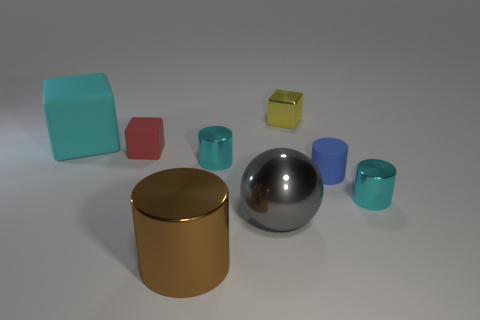What material is the red thing?
Offer a very short reply. Rubber. There is a big object left of the small cube in front of the cyan rubber cube behind the large gray metal object; what is it made of?
Offer a terse response. Rubber. Does the blue rubber cylinder have the same size as the block that is on the right side of the brown object?
Ensure brevity in your answer.  Yes. How many objects are either small objects left of the big shiny cylinder or matte blocks that are behind the red cube?
Your response must be concise. 2. The tiny block left of the brown metallic thing is what color?
Offer a very short reply. Red. Is there a small blue object that is in front of the block that is on the right side of the big brown metallic thing?
Provide a succinct answer. Yes. Is the number of big objects less than the number of tiny green matte cylinders?
Your response must be concise. No. There is a tiny block that is left of the block to the right of the big gray metal ball; what is its material?
Keep it short and to the point. Rubber. Is the size of the gray ball the same as the cyan cube?
Your answer should be very brief. Yes. What number of things are either tiny gray matte spheres or tiny cyan metal cylinders?
Provide a succinct answer. 2. 